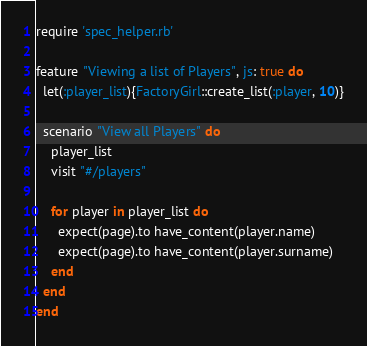<code> <loc_0><loc_0><loc_500><loc_500><_Ruby_>require 'spec_helper.rb'

feature "Viewing a list of Players", js: true do
  let(:player_list){FactoryGirl::create_list(:player, 10)}

  scenario "View all Players" do
    player_list
    visit "#/players"

    for player in player_list do
      expect(page).to have_content(player.name)
      expect(page).to have_content(player.surname)
    end
  end
end
</code> 